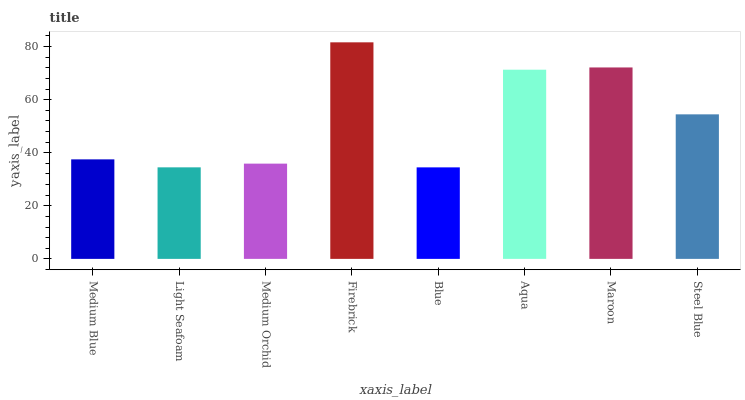Is Blue the minimum?
Answer yes or no. Yes. Is Firebrick the maximum?
Answer yes or no. Yes. Is Light Seafoam the minimum?
Answer yes or no. No. Is Light Seafoam the maximum?
Answer yes or no. No. Is Medium Blue greater than Light Seafoam?
Answer yes or no. Yes. Is Light Seafoam less than Medium Blue?
Answer yes or no. Yes. Is Light Seafoam greater than Medium Blue?
Answer yes or no. No. Is Medium Blue less than Light Seafoam?
Answer yes or no. No. Is Steel Blue the high median?
Answer yes or no. Yes. Is Medium Blue the low median?
Answer yes or no. Yes. Is Light Seafoam the high median?
Answer yes or no. No. Is Aqua the low median?
Answer yes or no. No. 